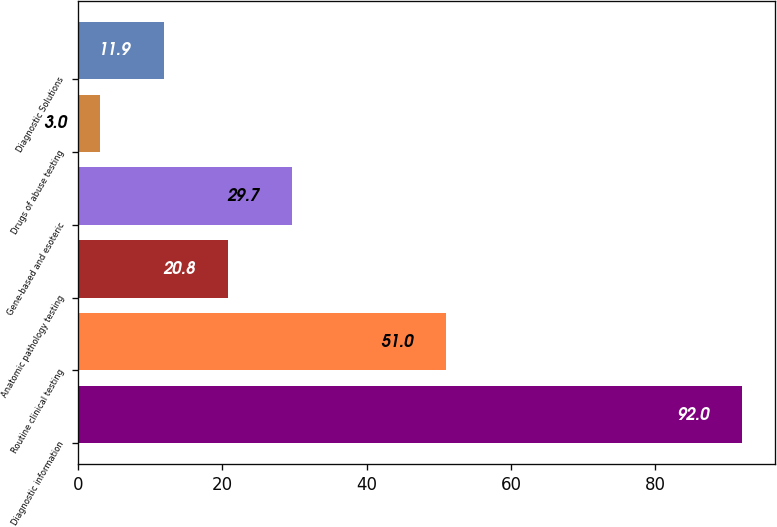Convert chart to OTSL. <chart><loc_0><loc_0><loc_500><loc_500><bar_chart><fcel>Diagnostic information<fcel>Routine clinical testing<fcel>Anatomic pathology testing<fcel>Gene-based and esoteric<fcel>Drugs of abuse testing<fcel>Diagnostic Solutions<nl><fcel>92<fcel>51<fcel>20.8<fcel>29.7<fcel>3<fcel>11.9<nl></chart> 